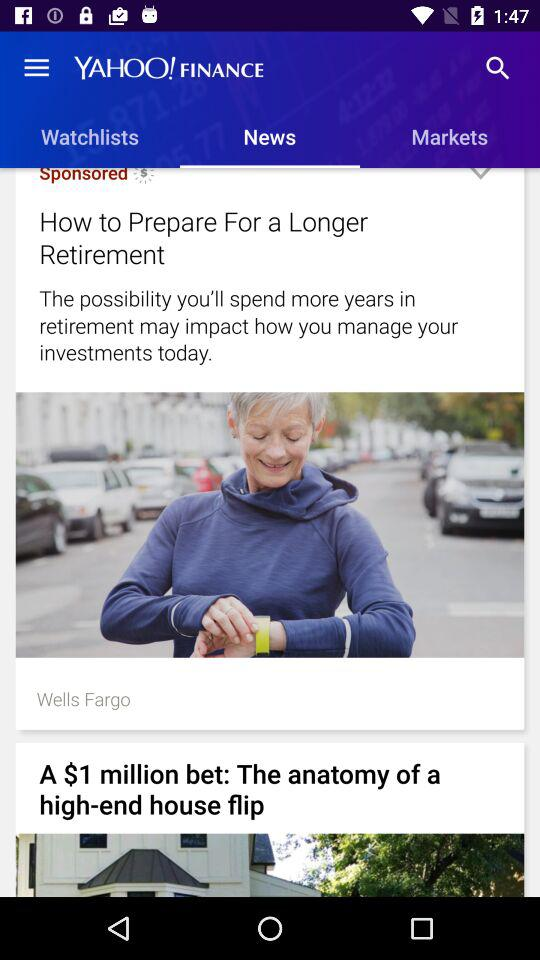What is the selected tab? The selected tab is "News". 